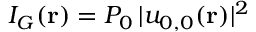Convert formula to latex. <formula><loc_0><loc_0><loc_500><loc_500>I _ { G } ( r ) = P _ { 0 } \, | u _ { 0 , 0 } ( r ) | ^ { 2 }</formula> 